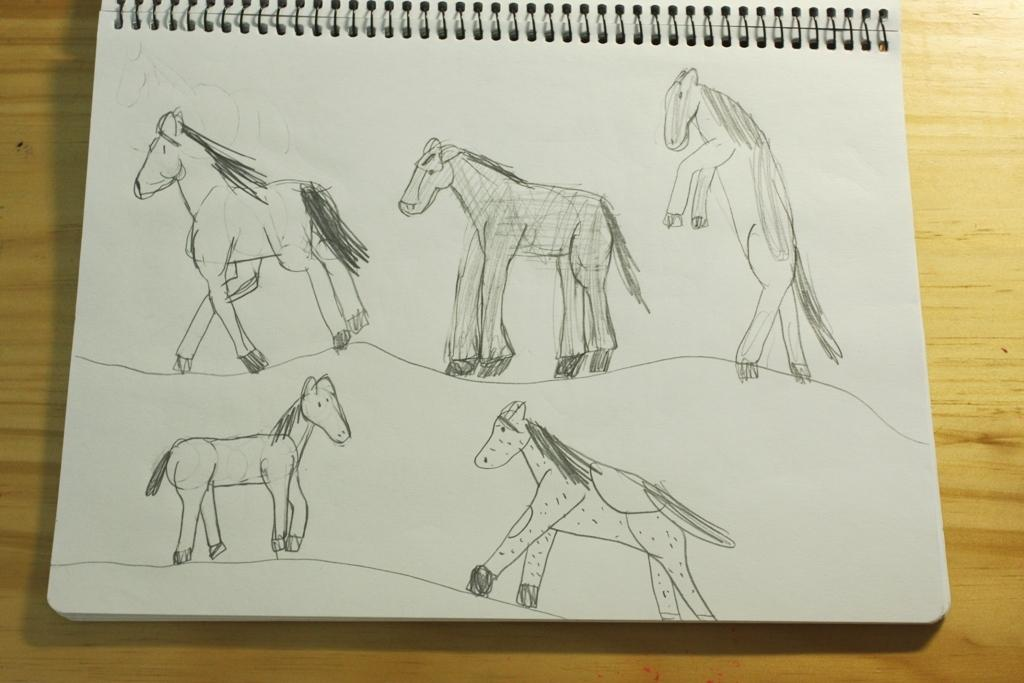What is present on the table in the image? There is a book on the table in the image. What is inside the book? The book contains a painting of an animal. What type of camp can be seen in the image? There is no camp present in the image; it features a table with a book containing a painting of an animal. What legal advice can be obtained from the book in the image? The book in the image is not a legal document or resource, so it does not provide any legal advice. 